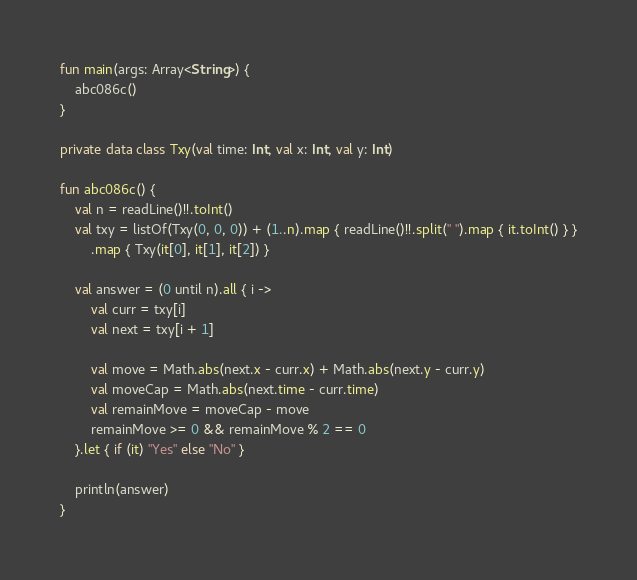<code> <loc_0><loc_0><loc_500><loc_500><_Kotlin_>fun main(args: Array<String>) {
    abc086c()
}

private data class Txy(val time: Int, val x: Int, val y: Int)

fun abc086c() {
    val n = readLine()!!.toInt()
    val txy = listOf(Txy(0, 0, 0)) + (1..n).map { readLine()!!.split(" ").map { it.toInt() } }
        .map { Txy(it[0], it[1], it[2]) }

    val answer = (0 until n).all { i ->
        val curr = txy[i]
        val next = txy[i + 1]

        val move = Math.abs(next.x - curr.x) + Math.abs(next.y - curr.y)
        val moveCap = Math.abs(next.time - curr.time)
        val remainMove = moveCap - move
        remainMove >= 0 && remainMove % 2 == 0
    }.let { if (it) "Yes" else "No" }

    println(answer)
}
</code> 